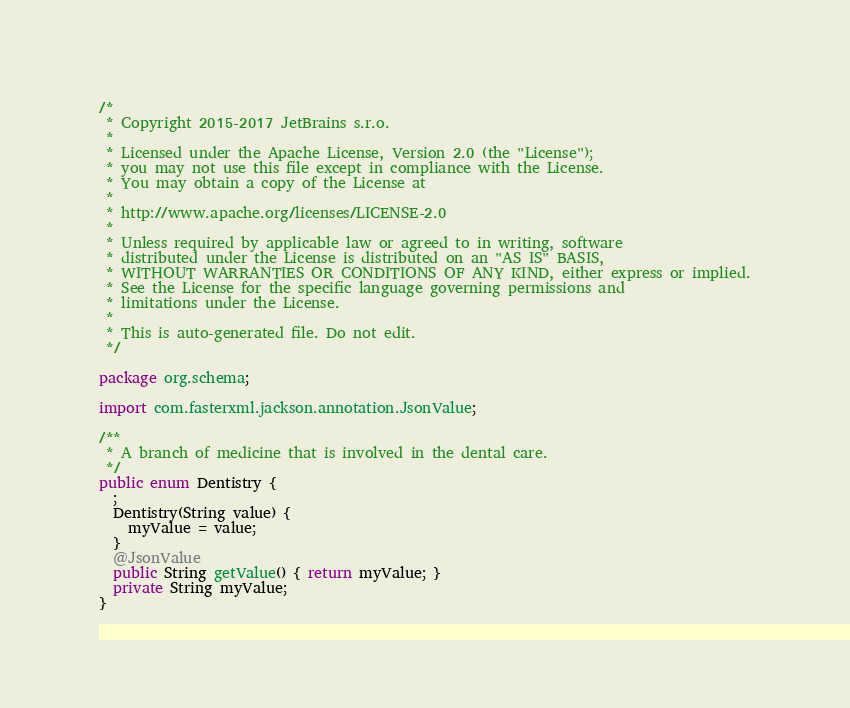<code> <loc_0><loc_0><loc_500><loc_500><_Java_>/*
 * Copyright 2015-2017 JetBrains s.r.o.
 *
 * Licensed under the Apache License, Version 2.0 (the "License");
 * you may not use this file except in compliance with the License.
 * You may obtain a copy of the License at
 *
 * http://www.apache.org/licenses/LICENSE-2.0
 *
 * Unless required by applicable law or agreed to in writing, software
 * distributed under the License is distributed on an "AS IS" BASIS,
 * WITHOUT WARRANTIES OR CONDITIONS OF ANY KIND, either express or implied.
 * See the License for the specific language governing permissions and
 * limitations under the License.
 *
 * This is auto-generated file. Do not edit.
 */

package org.schema;

import com.fasterxml.jackson.annotation.JsonValue;

/**
 * A branch of medicine that is involved in the dental care.
 */
public enum Dentistry {
  ;
  Dentistry(String value) {
    myValue = value;
  }
  @JsonValue
  public String getValue() { return myValue; }
  private String myValue;
}
</code> 